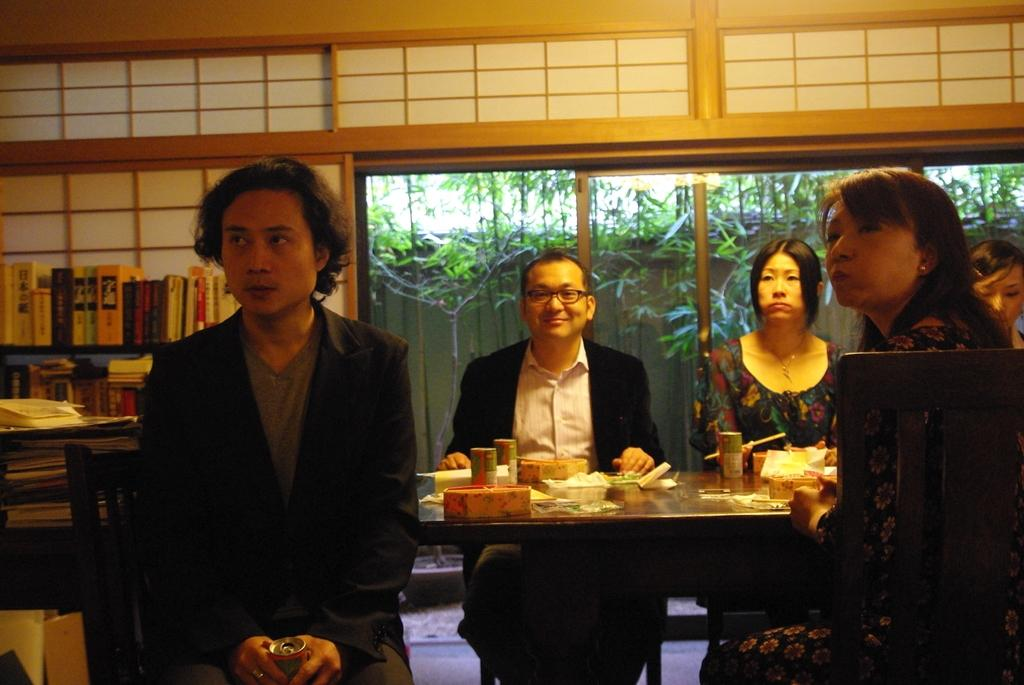What can be seen in the image that allows for a view of the outdoors? There is a window in the image that provides a view of the outdoors. What is visible through the window in the image? Trees are visible through the window in the image. What are the people in the image doing? There are people sitting on chairs in the image. What objects might be used for reading or studying in the image? Books are present in the image. What piece of furniture is present in the image that might be used for placing objects or for eating? There is a table in the image. What type of company is conducting a meeting in the image? There is no indication of a company or a meeting in the image. What is the plot of the story being told in the image? There is no story or plot depicted in the image. 